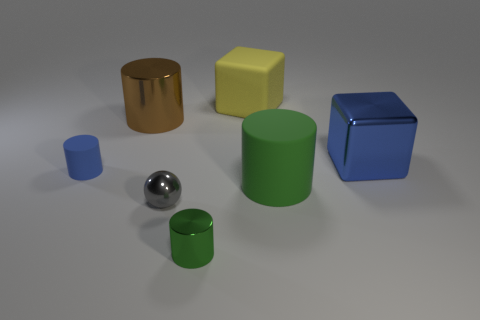Subtract all yellow cylinders. Subtract all purple balls. How many cylinders are left? 4 Add 2 big yellow rubber things. How many objects exist? 9 Subtract all balls. How many objects are left? 6 Add 4 large brown shiny cylinders. How many large brown shiny cylinders are left? 5 Add 6 green rubber balls. How many green rubber balls exist? 6 Subtract 0 red cubes. How many objects are left? 7 Subtract all blue things. Subtract all gray balls. How many objects are left? 4 